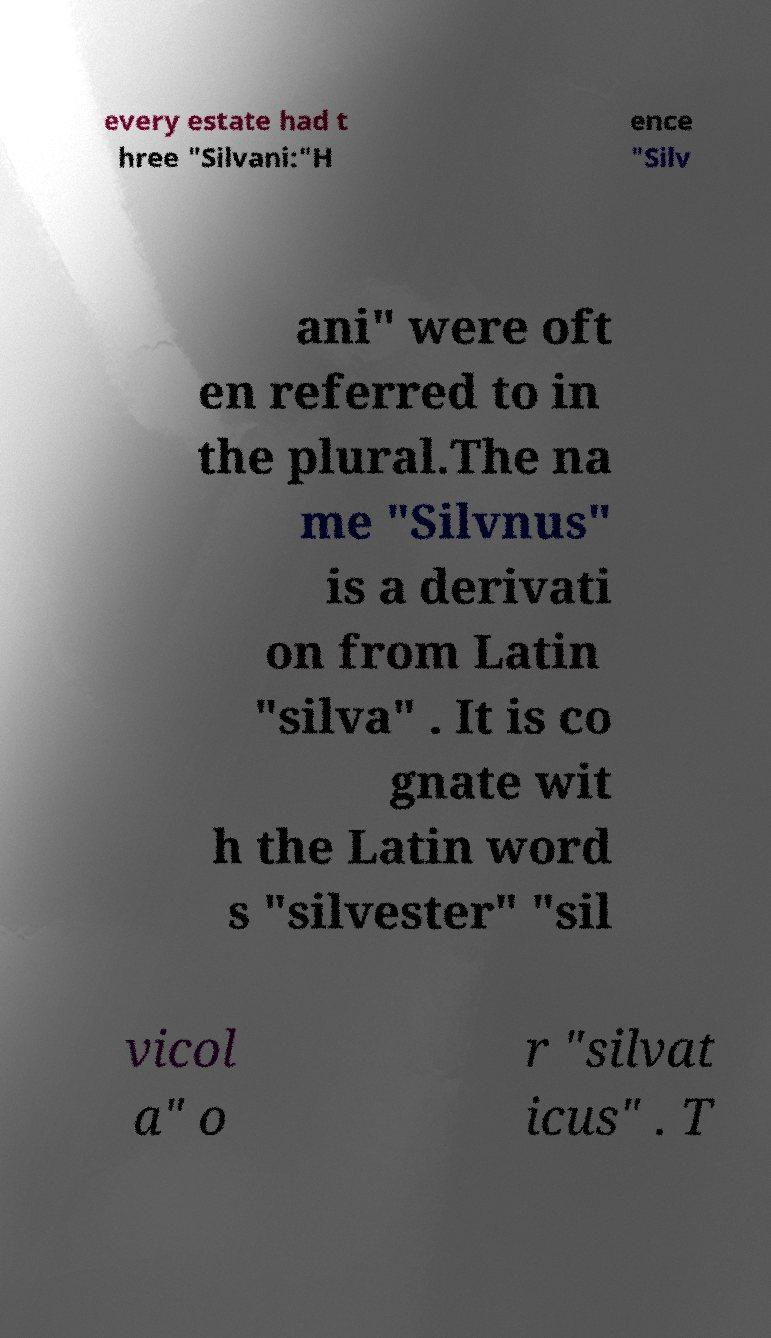Please read and relay the text visible in this image. What does it say? every estate had t hree "Silvani:"H ence "Silv ani" were oft en referred to in the plural.The na me "Silvnus" is a derivati on from Latin "silva" . It is co gnate wit h the Latin word s "silvester" "sil vicol a" o r "silvat icus" . T 